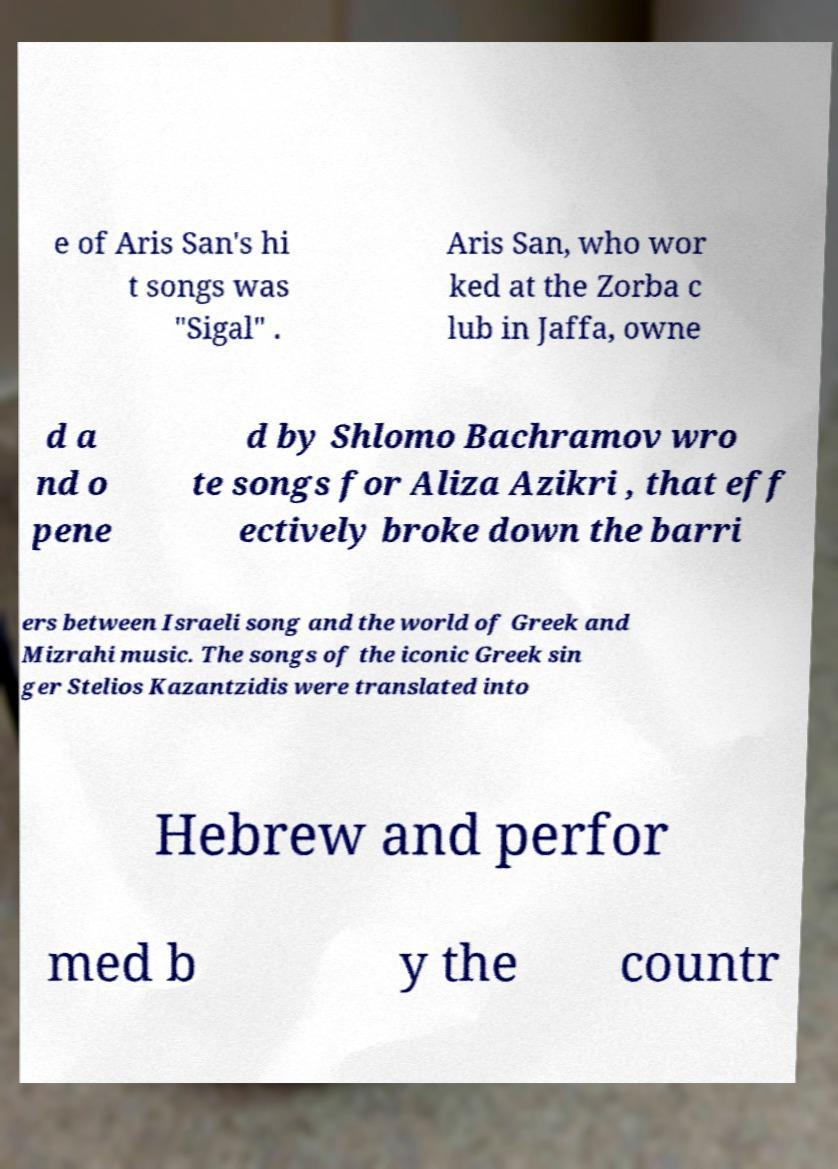Please read and relay the text visible in this image. What does it say? e of Aris San's hi t songs was "Sigal" . Aris San, who wor ked at the Zorba c lub in Jaffa, owne d a nd o pene d by Shlomo Bachramov wro te songs for Aliza Azikri , that eff ectively broke down the barri ers between Israeli song and the world of Greek and Mizrahi music. The songs of the iconic Greek sin ger Stelios Kazantzidis were translated into Hebrew and perfor med b y the countr 